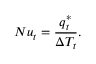Convert formula to latex. <formula><loc_0><loc_0><loc_500><loc_500>N u _ { t } = \frac { q _ { t } ^ { * } } { \Delta T _ { t } } .</formula> 